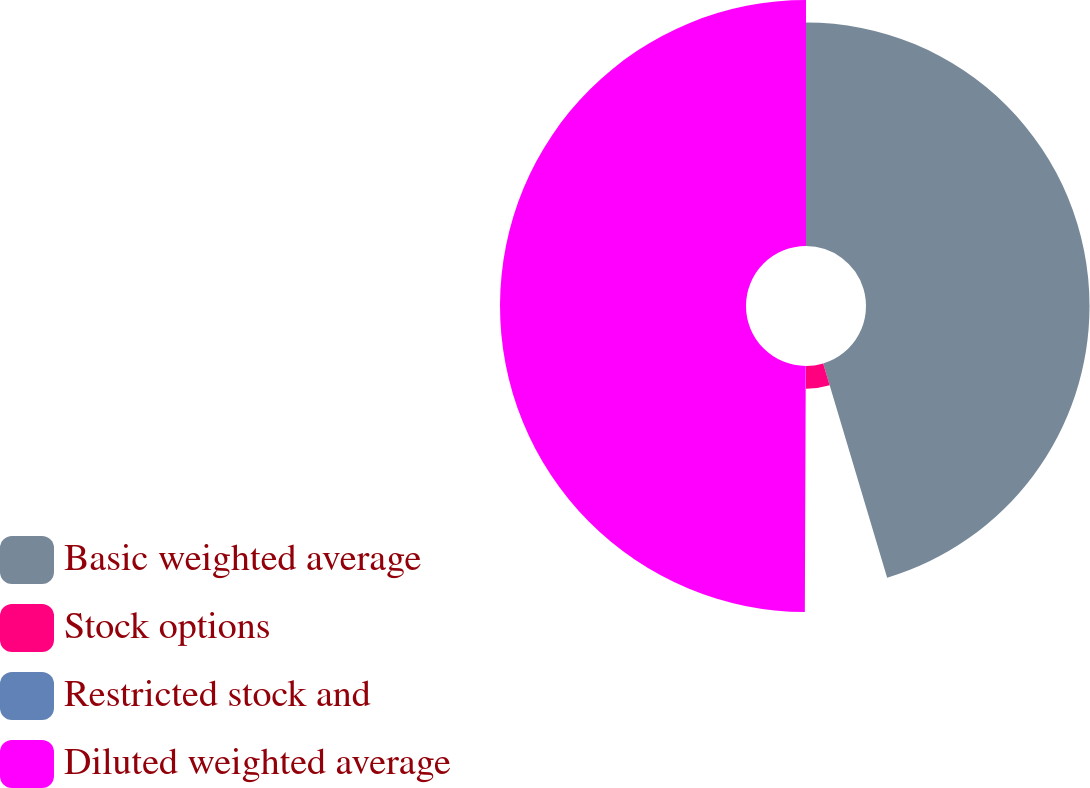<chart> <loc_0><loc_0><loc_500><loc_500><pie_chart><fcel>Basic weighted average<fcel>Stock options<fcel>Restricted stock and<fcel>Diluted weighted average<nl><fcel>45.38%<fcel>4.62%<fcel>0.06%<fcel>49.94%<nl></chart> 